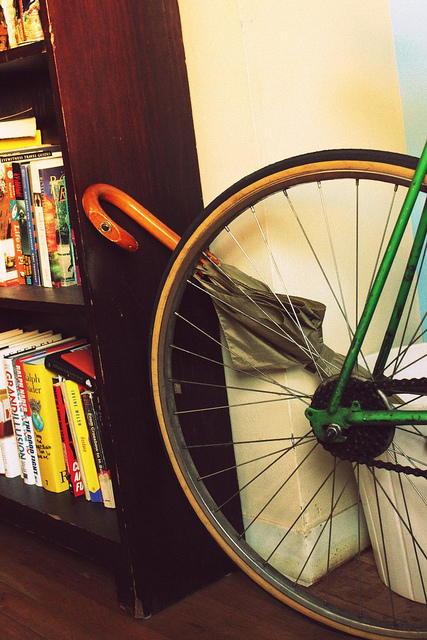What genres of books does the bookshelf contain? The bookshelf seems to hold a variety of genres, including what appear to be fiction novels, some possible science or history-related non-fiction, and at least one or two travel guides, judging by the spines and visible cover designs. 